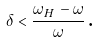<formula> <loc_0><loc_0><loc_500><loc_500>\delta < \frac { \omega _ { H } - \omega } { \omega } \text {.}</formula> 